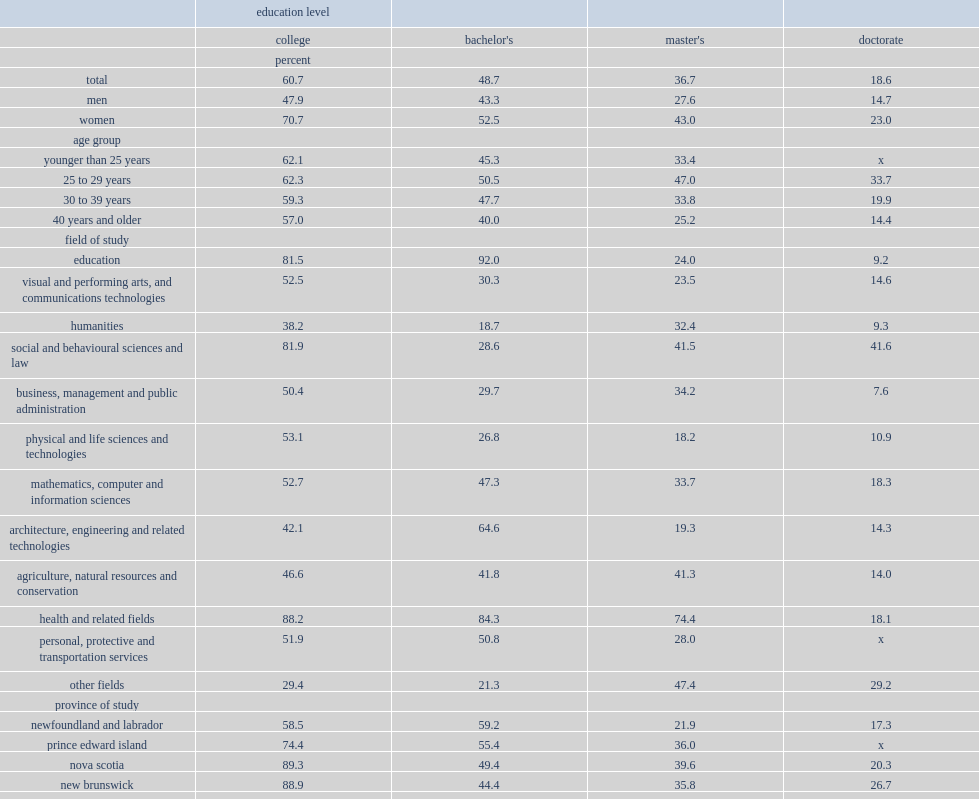What is the proportion of postsecondary graduates reported having participated in wil during their postsecondary studies? 48.7. Which education level of graduates mostly likely to have participated in wil during their studies? College. What is the percentage of college graduates have participated in wil during their studies? 60.7. What is the percentage of bachelor's graduates have participated in wil? 48.7. What is the percentage of master's graduates have participated in wil? 36.7. What is the percentage of doctoral graduates have participated in wil? 18.6. What is the percentage of college graduates from nova scotia participated in wil? 89.3. What is the proportion of college graduates from new brunswick participated in wil? 88.9. What is the percentage of college graduates from ontario participated in wil? 57.2. At which education level,the gap between the participation rate of men and women was largest? College. At the college levels,what is the percentage of graduates in education programs participated in wil? 81.5. At the bachelor's levels,what is the percentage of graduates in education programs participated in wil? 92.0. What is the participation rate that graduates in the field of social and behavioural sciences and law at the college level had? 81.9. At the bachelor's level, what is participation rate the graduates in the field of architecture, engineering and related technologies had? 64.6. At the bachelor's level,what is the percentage that the participation rate of graduates in the field of architecture, engineering and related technologies higher than the rate of all bachelor's graduates? 15.9. In which field graduates had the lowest participation rate at the bachelor's level? Humanities. What is the the participation rate humanities graduates had at the bachelor's level? 18.7. Among master's graduates, what is the participation rates graduates in health and related fields had? 74.4. Among master's graduates,in which field graduates had the lowest participation rate? Physical and life sciences and technologies. Among doctoral graduates,what is the percentage of graduates in the field of social and behavioural sciences and law have participated in wil during their studies? 41.6. What is the percentage of doctoral graduates in business, management and public administration participated in wil? 7.6. 